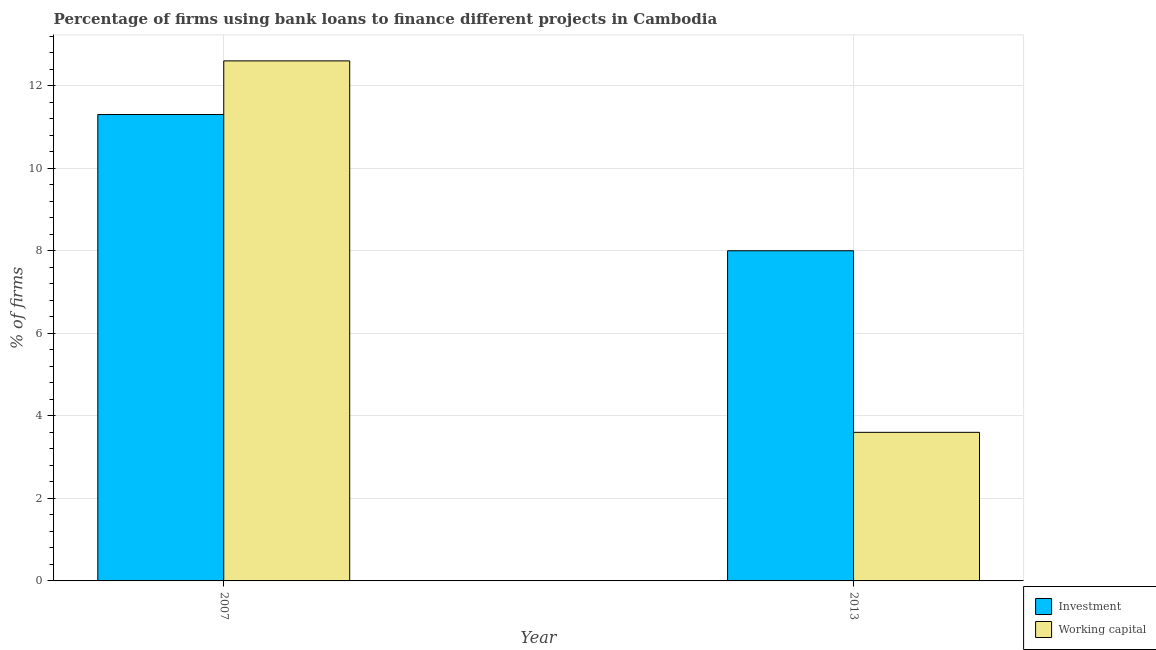How many different coloured bars are there?
Give a very brief answer. 2. How many groups of bars are there?
Your answer should be very brief. 2. How many bars are there on the 1st tick from the left?
Ensure brevity in your answer.  2. What is the label of the 2nd group of bars from the left?
Give a very brief answer. 2013. In how many cases, is the number of bars for a given year not equal to the number of legend labels?
Give a very brief answer. 0. Across all years, what is the minimum percentage of firms using banks to finance investment?
Offer a very short reply. 8. What is the difference between the percentage of firms using banks to finance working capital in 2007 and that in 2013?
Make the answer very short. 9. What is the difference between the percentage of firms using banks to finance working capital in 2013 and the percentage of firms using banks to finance investment in 2007?
Provide a short and direct response. -9. What is the average percentage of firms using banks to finance investment per year?
Your answer should be very brief. 9.65. In the year 2013, what is the difference between the percentage of firms using banks to finance investment and percentage of firms using banks to finance working capital?
Offer a very short reply. 0. Is the percentage of firms using banks to finance working capital in 2007 less than that in 2013?
Your answer should be compact. No. In how many years, is the percentage of firms using banks to finance investment greater than the average percentage of firms using banks to finance investment taken over all years?
Provide a short and direct response. 1. What does the 1st bar from the left in 2007 represents?
Provide a short and direct response. Investment. What does the 2nd bar from the right in 2007 represents?
Your answer should be very brief. Investment. How many years are there in the graph?
Provide a short and direct response. 2. What is the difference between two consecutive major ticks on the Y-axis?
Offer a terse response. 2. Where does the legend appear in the graph?
Your answer should be very brief. Bottom right. How are the legend labels stacked?
Give a very brief answer. Vertical. What is the title of the graph?
Give a very brief answer. Percentage of firms using bank loans to finance different projects in Cambodia. What is the label or title of the Y-axis?
Provide a short and direct response. % of firms. What is the % of firms of Investment in 2007?
Your response must be concise. 11.3. What is the % of firms of Working capital in 2007?
Provide a short and direct response. 12.6. What is the % of firms in Working capital in 2013?
Offer a very short reply. 3.6. Across all years, what is the minimum % of firms in Investment?
Ensure brevity in your answer.  8. What is the total % of firms of Investment in the graph?
Your answer should be compact. 19.3. What is the difference between the % of firms in Investment in 2007 and that in 2013?
Make the answer very short. 3.3. What is the difference between the % of firms in Investment in 2007 and the % of firms in Working capital in 2013?
Your answer should be very brief. 7.7. What is the average % of firms of Investment per year?
Provide a succinct answer. 9.65. In the year 2013, what is the difference between the % of firms in Investment and % of firms in Working capital?
Keep it short and to the point. 4.4. What is the ratio of the % of firms in Investment in 2007 to that in 2013?
Your answer should be very brief. 1.41. What is the ratio of the % of firms of Working capital in 2007 to that in 2013?
Provide a short and direct response. 3.5. What is the difference between the highest and the lowest % of firms of Working capital?
Provide a short and direct response. 9. 